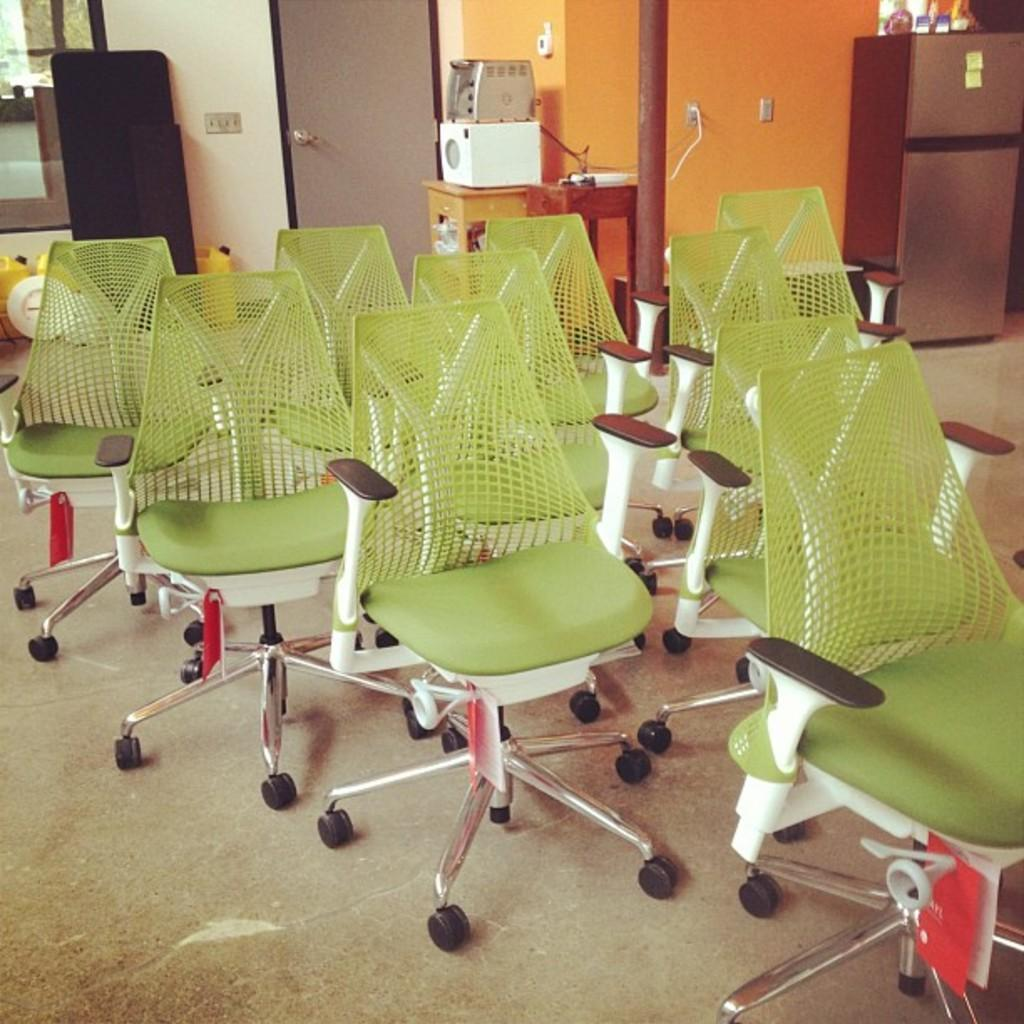What type of furniture is on the floor in the image? There are chairs on the floor in the image. What can be seen in the background of the image? In the background, there is a door, a refrigerator, a switch board, a table, a bread maker, and a wall. Can you describe the wall in the background? The wall in the background is plain and does not have any decorations or features mentioned in the facts. What type of coil is present on the bread maker in the image? There is no coil mentioned or visible on the bread maker in the image. How many bananas are on the table in the image? There is no mention of bananas in the image; only a table is mentioned in the background. 